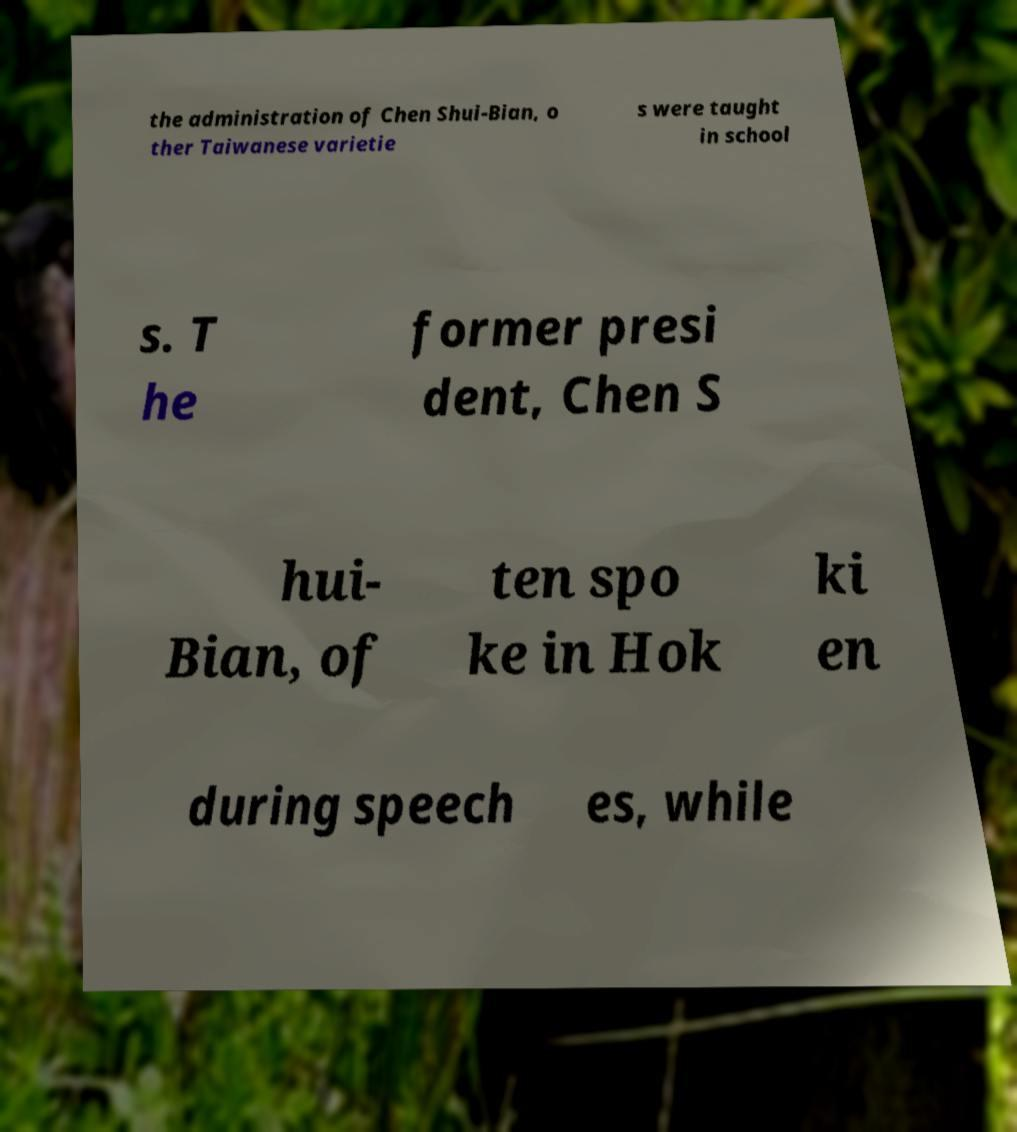There's text embedded in this image that I need extracted. Can you transcribe it verbatim? the administration of Chen Shui-Bian, o ther Taiwanese varietie s were taught in school s. T he former presi dent, Chen S hui- Bian, of ten spo ke in Hok ki en during speech es, while 